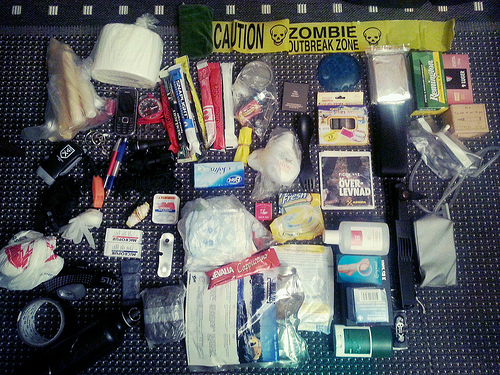<image>
Is there a phone above the toilet paper? No. The phone is not positioned above the toilet paper. The vertical arrangement shows a different relationship. 